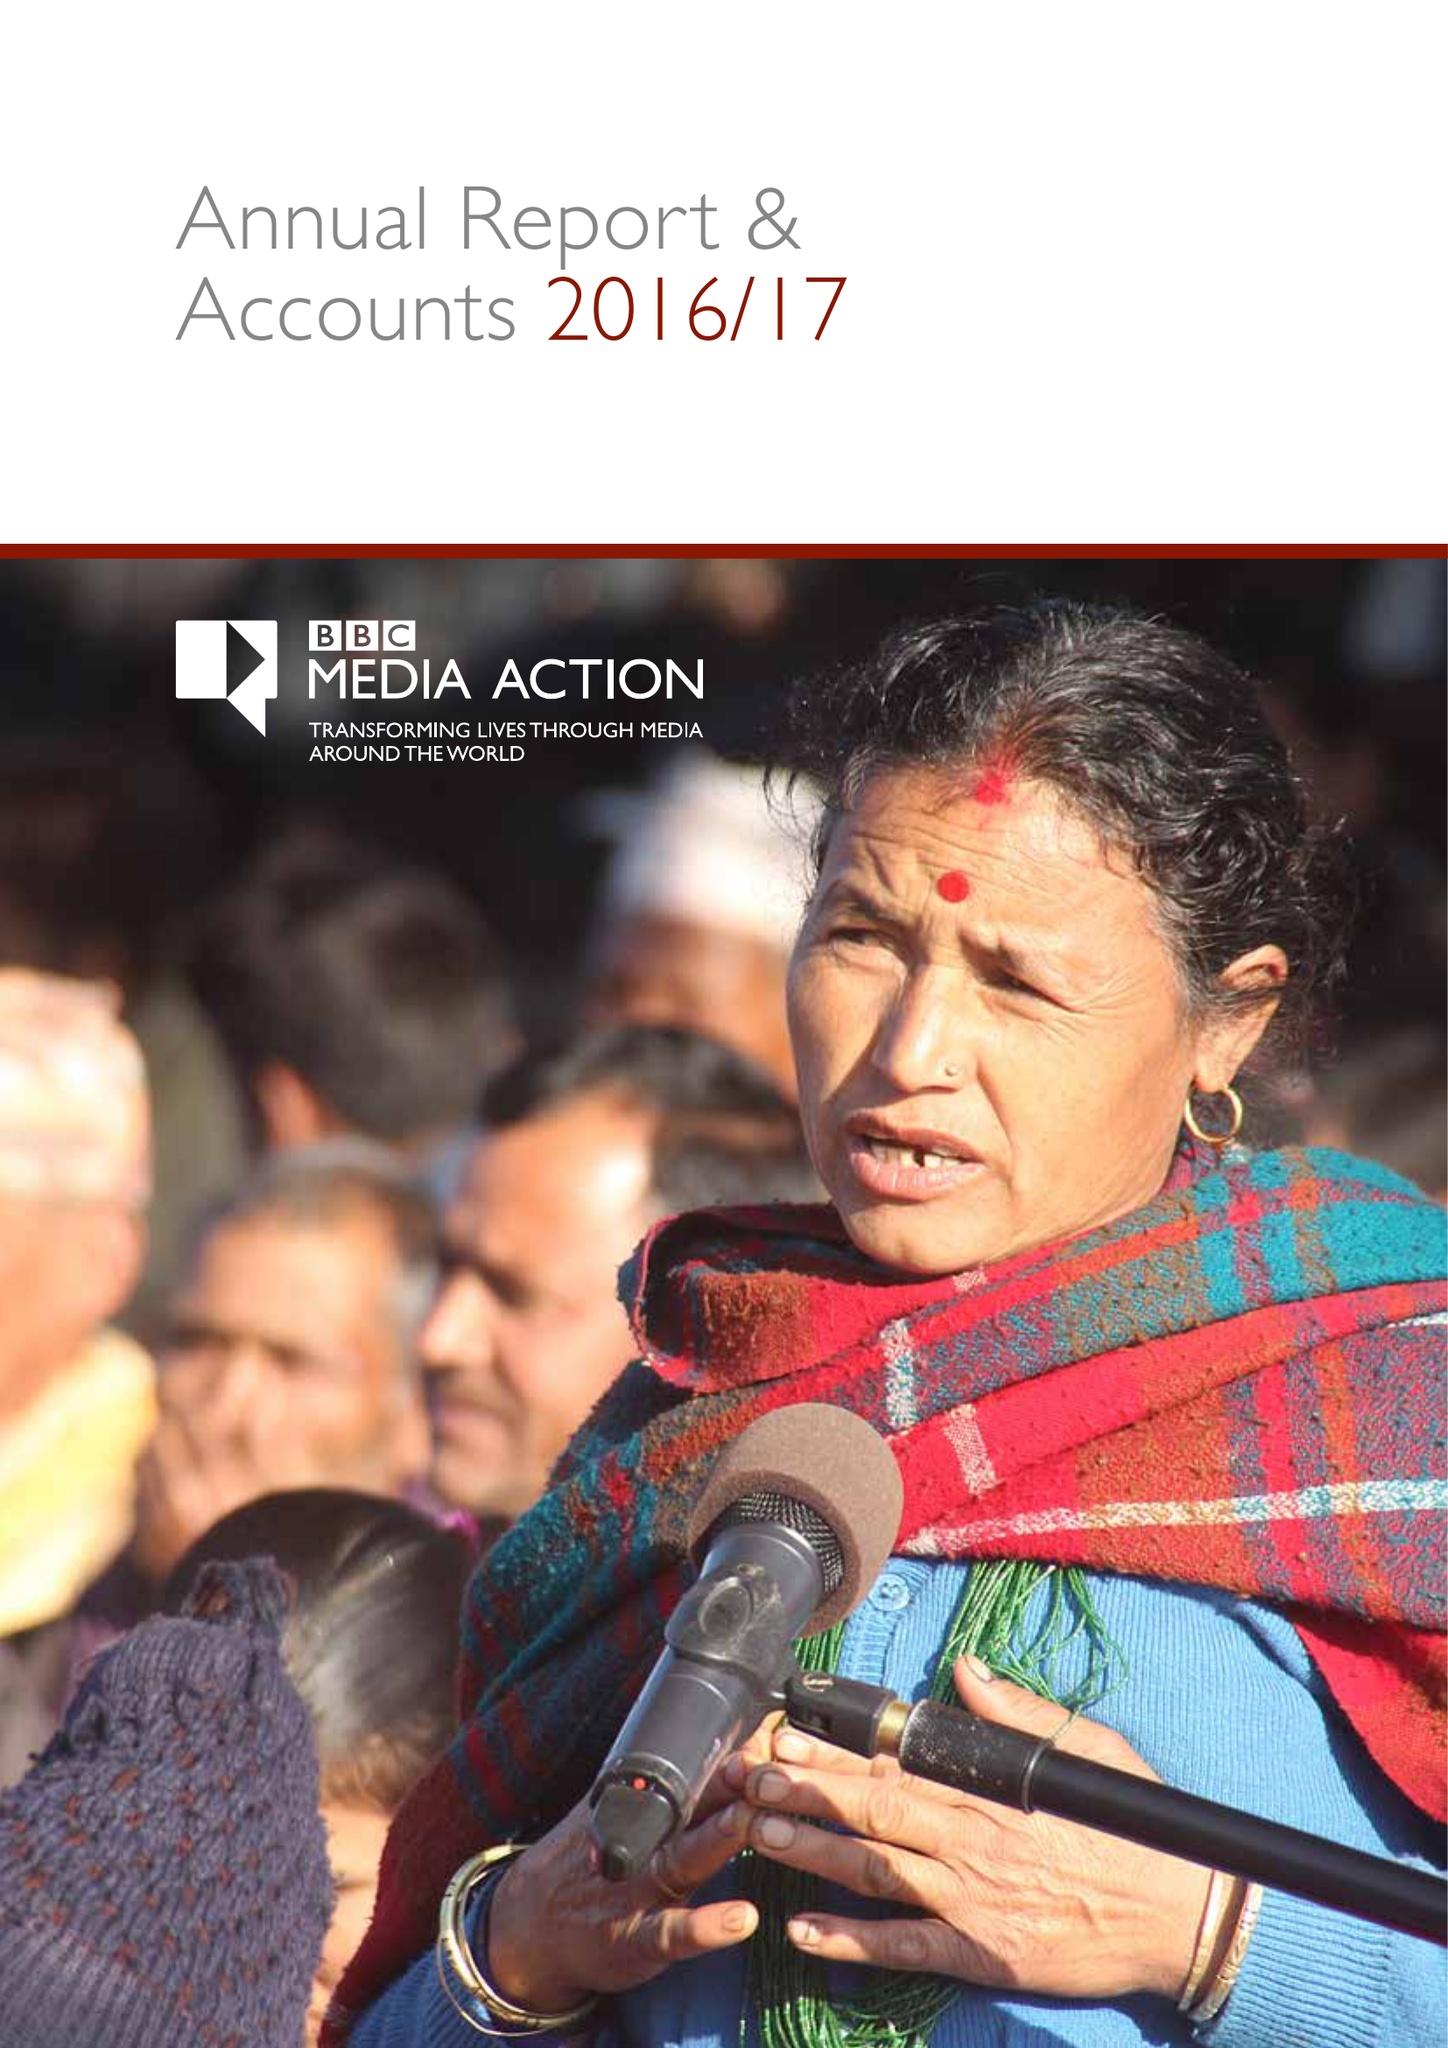What is the value for the charity_name?
Answer the question using a single word or phrase. Bbc Media Action 